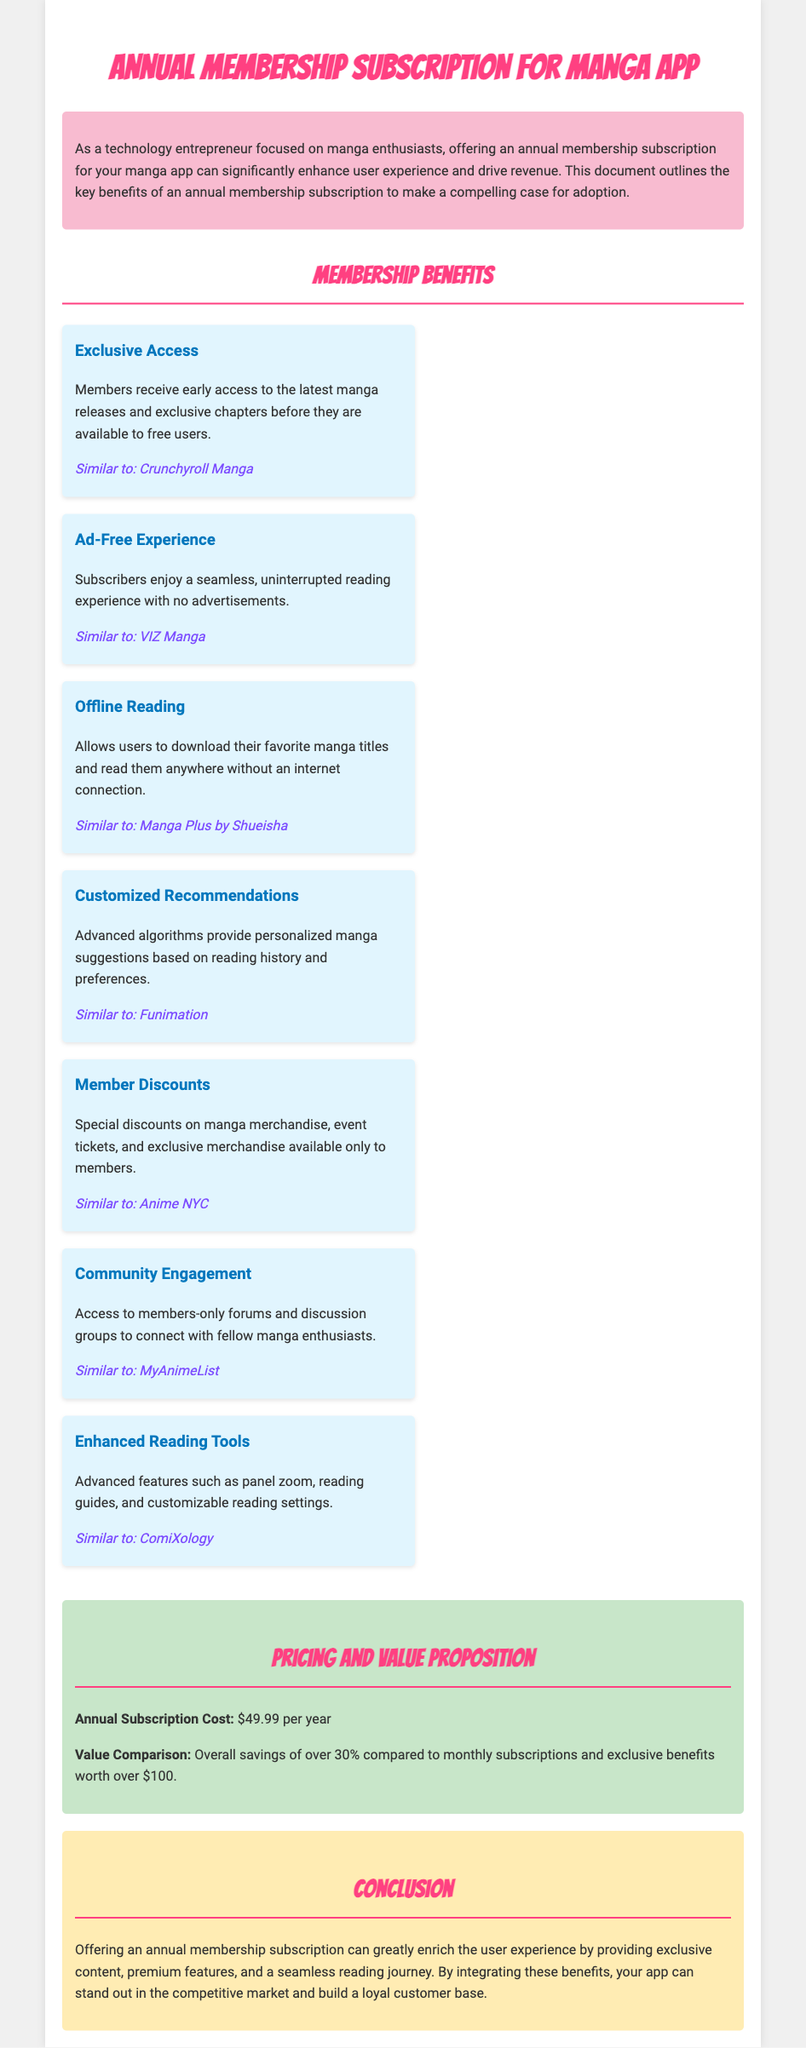What is the cost of the annual subscription? The document states that the annual subscription cost is prominently highlighted.
Answer: $49.99 per year What type of experience do subscribers enjoy? The document notes that subscribers have a specific benefit regarding advertisements.
Answer: Ad-Free Experience Which benefit allows users to read offline? The document specifically mentions a feature that supports reading without an internet connection.
Answer: Offline Reading What percentage can users save compared to monthly subscriptions? The value comparison section indicates the overall savings compared to alternative subscription methods.
Answer: Over 30% What is one of the community engagement features offered to members? The document lists a specific benefit related to connecting with others.
Answer: Members-only forums What similar service is mentioned with the "Enhanced Reading Tools" benefit? The document provides examples of similar services to enhance understanding.
Answer: ComiXology What does the document say about exclusive merchandise? The membership benefits section mentions discounts related to specific offerings.
Answer: Member Discounts Which company is noted as similar to "Exclusive Access"? The document compares this benefit to a popular manga service.
Answer: Crunchyroll Manga 